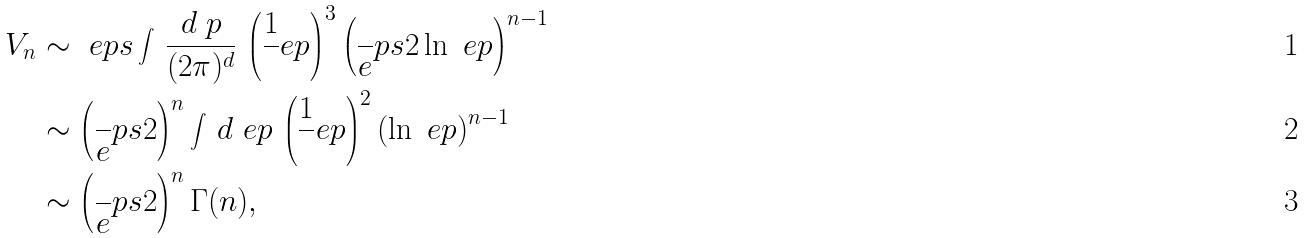Convert formula to latex. <formula><loc_0><loc_0><loc_500><loc_500>V _ { n } & \sim \ e p s \int \, \frac { d \ p } { ( 2 \pi ) ^ { d } } \, \left ( \frac { 1 } { \ } e p \right ) ^ { 3 } \left ( \frac { \ } { e } p s 2 \ln \ e p \right ) ^ { n - 1 } \\ & \sim \left ( \frac { \ } { e } p s 2 \right ) ^ { n } \int \, d \ e p \, \left ( \frac { 1 } { \ } e p \right ) ^ { 2 } \left ( \ln \ e p \right ) ^ { n - 1 } \\ & \sim \left ( \frac { \ } { e } p s 2 \right ) ^ { n } \Gamma ( n ) ,</formula> 